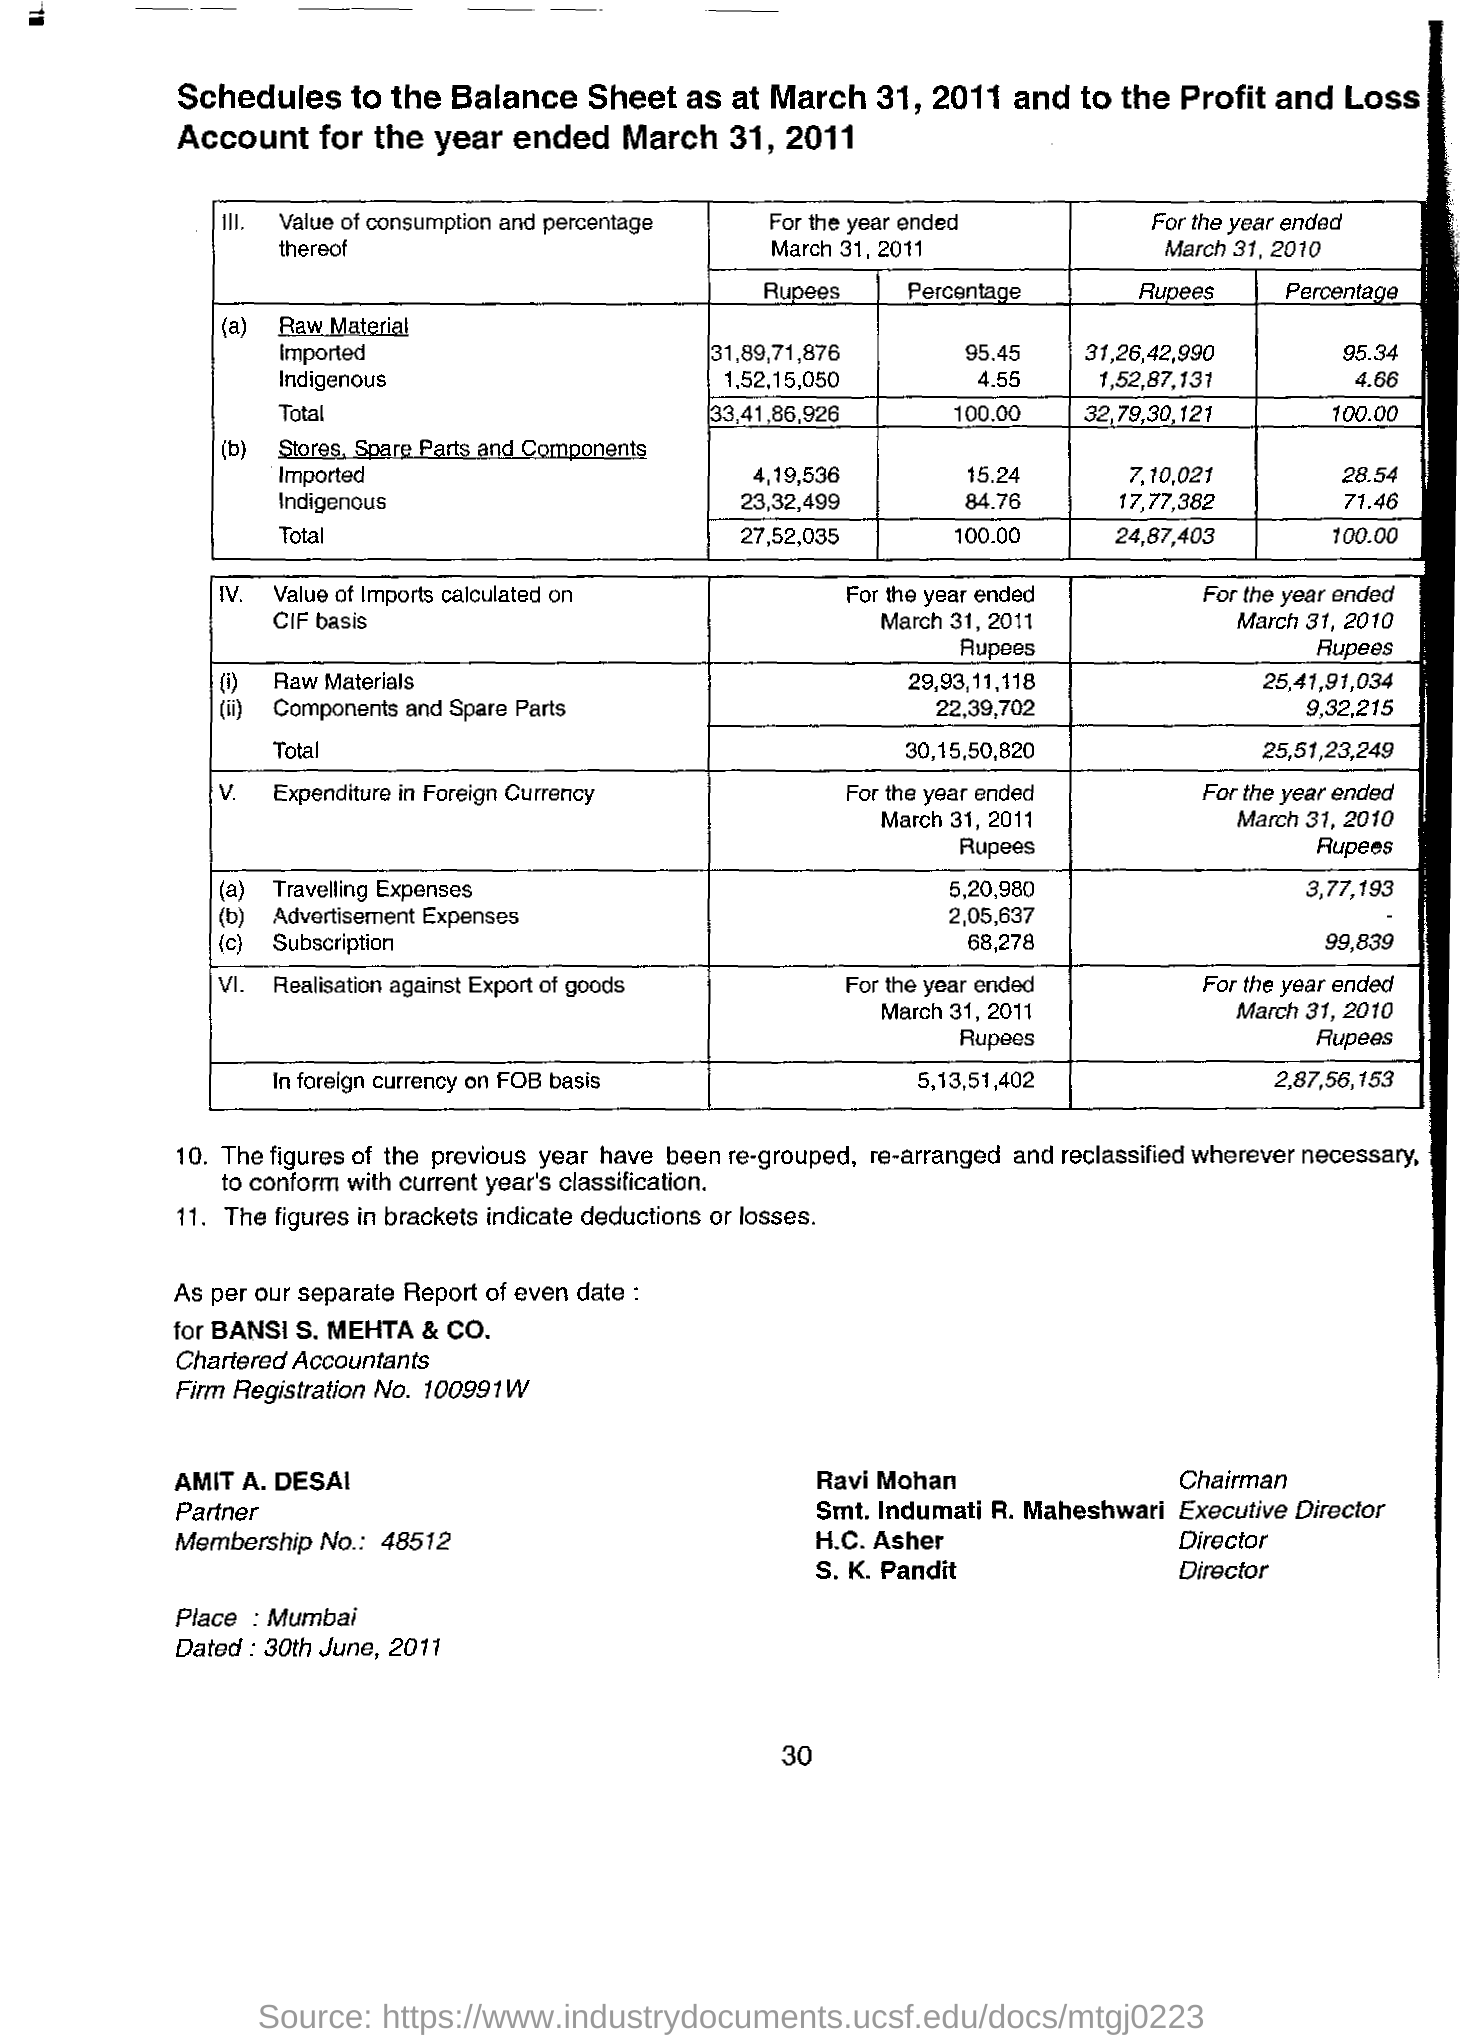Specify some key components in this picture. What is the membership number? The place name on the document is Mumbai. The person known as Ravi Mohan is the Chairman. On June 30, 2011, the Document was dated. 